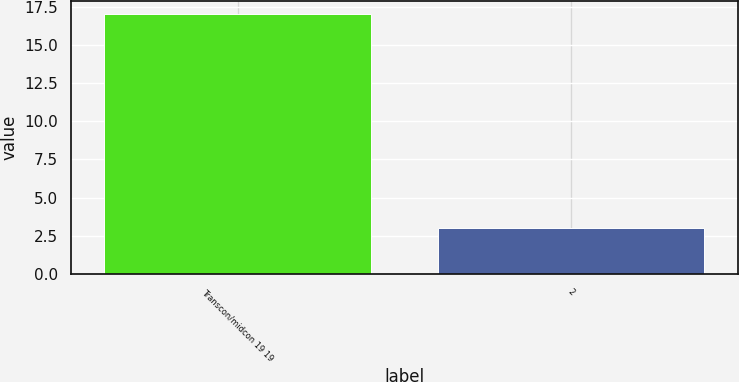Convert chart to OTSL. <chart><loc_0><loc_0><loc_500><loc_500><bar_chart><fcel>Transcon/midcon 19 19<fcel>2<nl><fcel>17<fcel>3<nl></chart> 